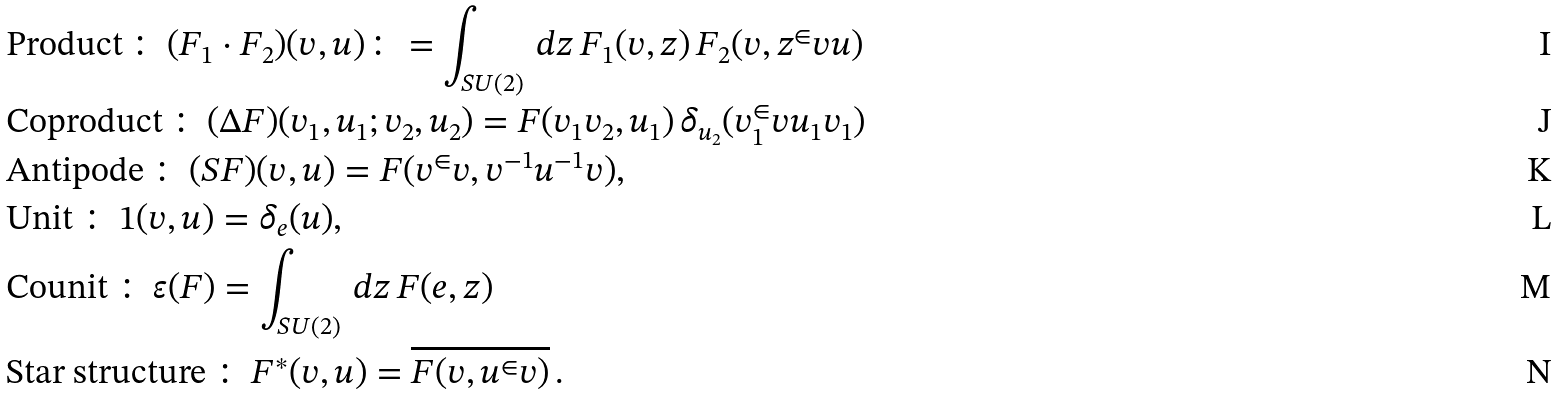Convert formula to latex. <formula><loc_0><loc_0><loc_500><loc_500>& \text {Product} \, \colon \, ( F _ { 1 } \cdot F _ { 2 } ) ( v , u ) \colon = \int _ { S U ( 2 ) } \, d z \, F _ { 1 } ( v , z ) \, F _ { 2 } ( v , z ^ { \in } v u ) \\ & \text {Coproduct} \, \colon \, ( \Delta F ) ( v _ { 1 } , u _ { 1 } ; v _ { 2 } , u _ { 2 } ) = F ( v _ { 1 } v _ { 2 } , u _ { 1 } ) \, \delta _ { u _ { 2 } } ( v _ { 1 } ^ { \in } v u _ { 1 } v _ { 1 } ) \\ & \text {Antipode} \, \colon \, ( S F ) ( v , u ) = F ( v ^ { \in } v , v ^ { - 1 } u ^ { - 1 } v ) , \\ & \text {Unit} \, \colon \, 1 ( v , u ) = \delta _ { e } ( u ) , \\ & \text {Counit} \, \colon \, \varepsilon ( F ) = \int _ { S U ( 2 ) } \, d z \, F ( e , z ) \\ & \text {Star structure} \, \colon \, F ^ { * } ( v , u ) = \overline { F ( v , u ^ { \in } v ) } \, .</formula> 